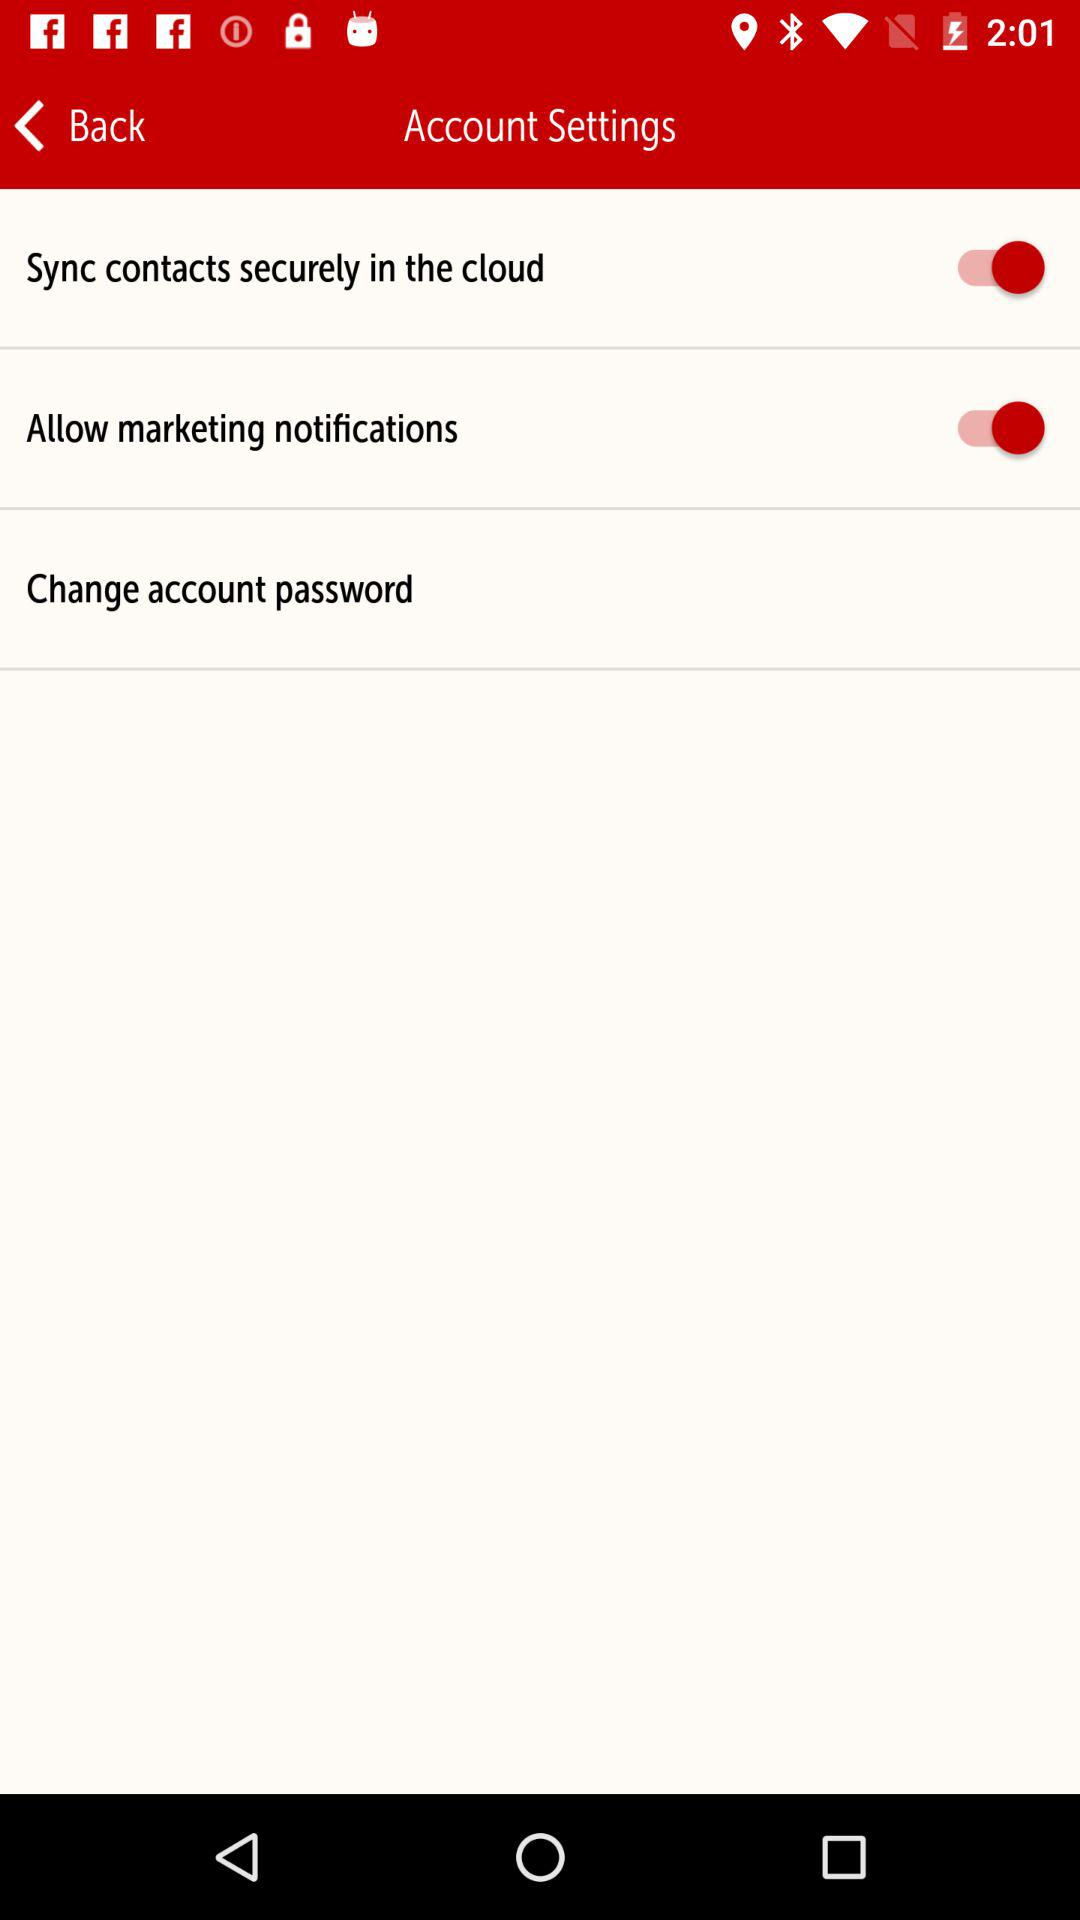What is the status of "Allow marketing notifications"? The status is "on". 